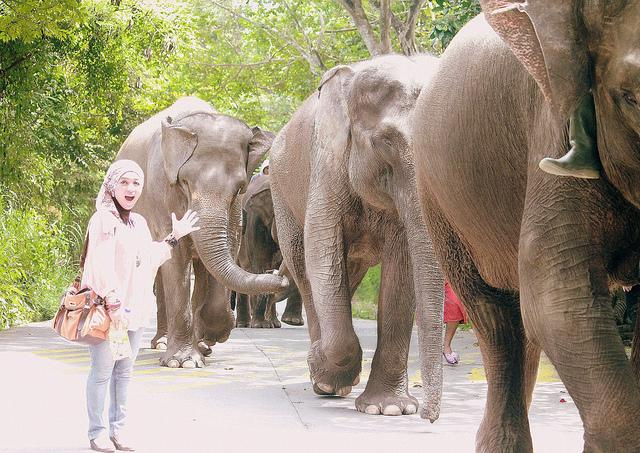What does this animal tend to have?

Choices:
A) wings
B) two trunks
C) sharp teeth
D) three hearts two trunks 